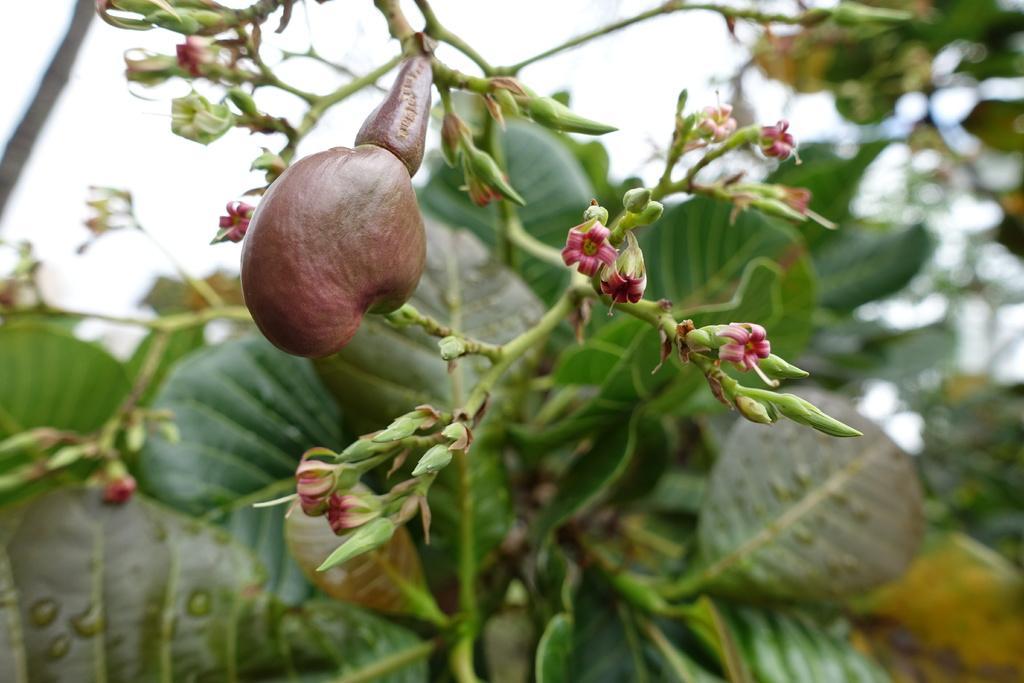Can you describe this image briefly? The picture consists of a plant with flowers, buds and fruit. In the background there is greenery and sky. 